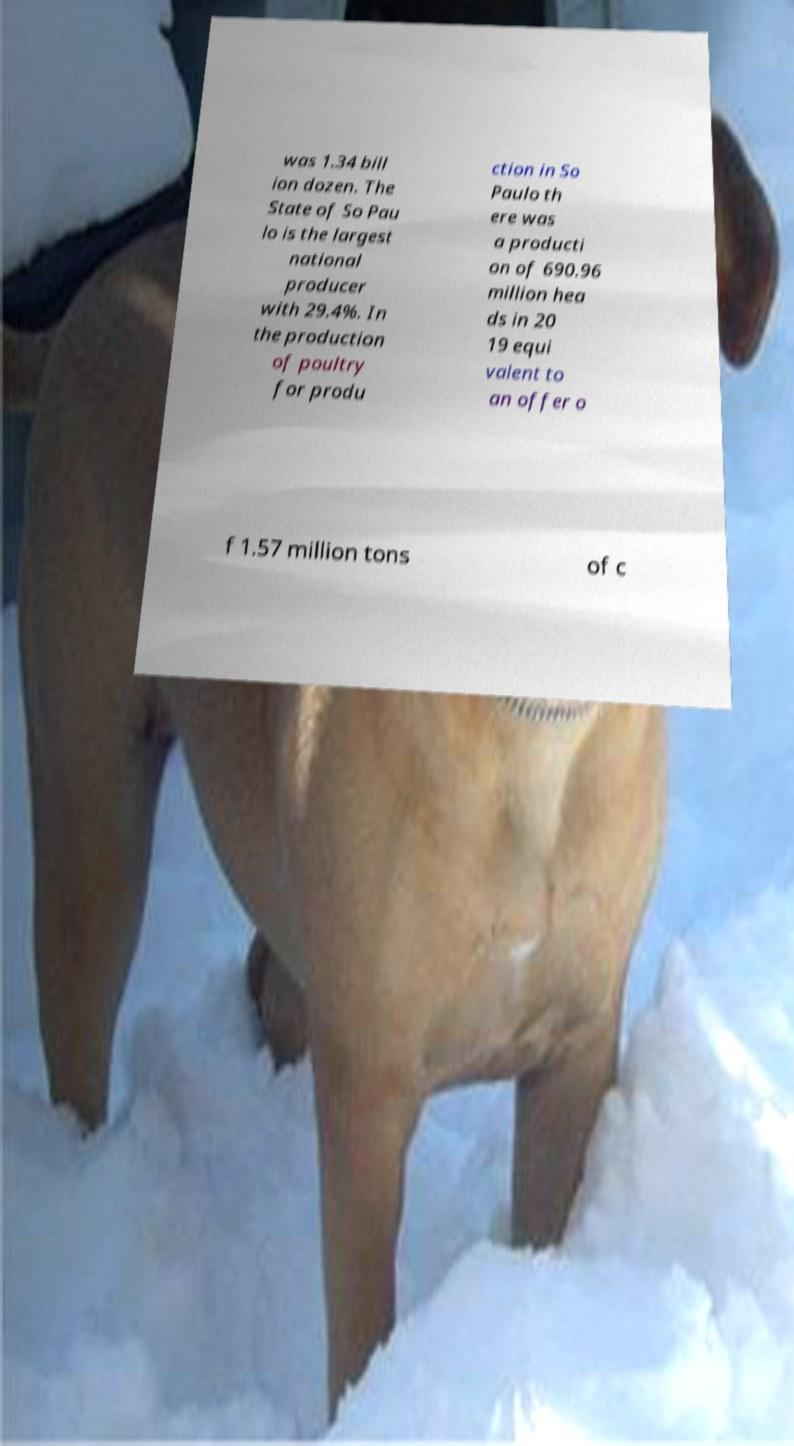For documentation purposes, I need the text within this image transcribed. Could you provide that? was 1.34 bill ion dozen. The State of So Pau lo is the largest national producer with 29.4%. In the production of poultry for produ ction in So Paulo th ere was a producti on of 690.96 million hea ds in 20 19 equi valent to an offer o f 1.57 million tons of c 